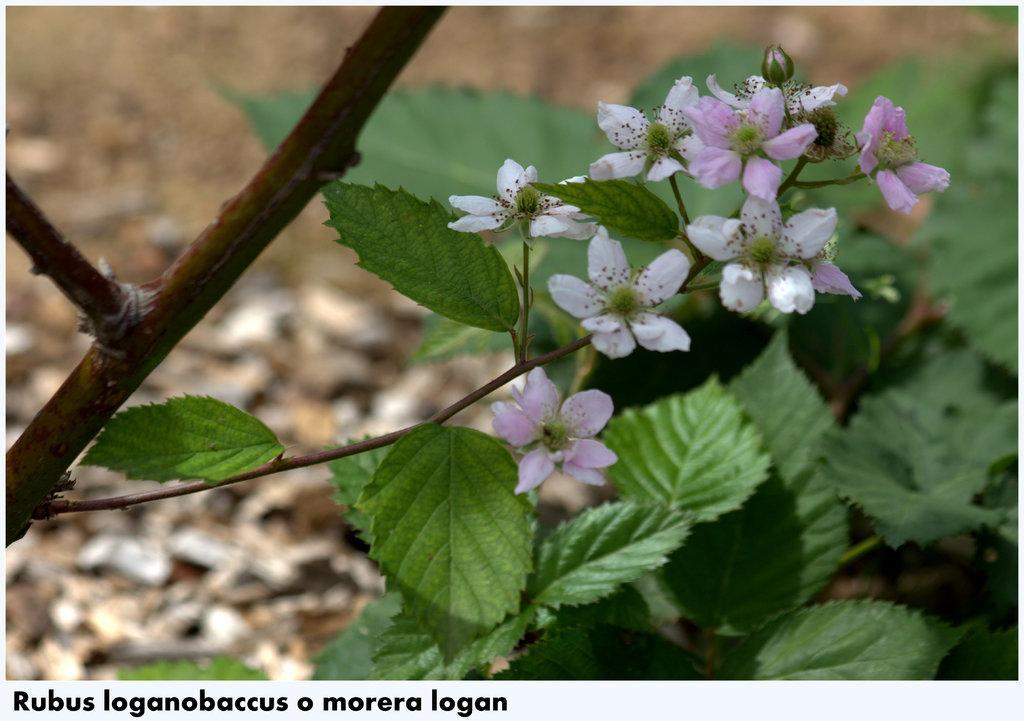Describe this image in one or two sentences. In this picture we can see flowers, plants and in the background we can see it is blurry, in the bottom left we can see some text on it. 